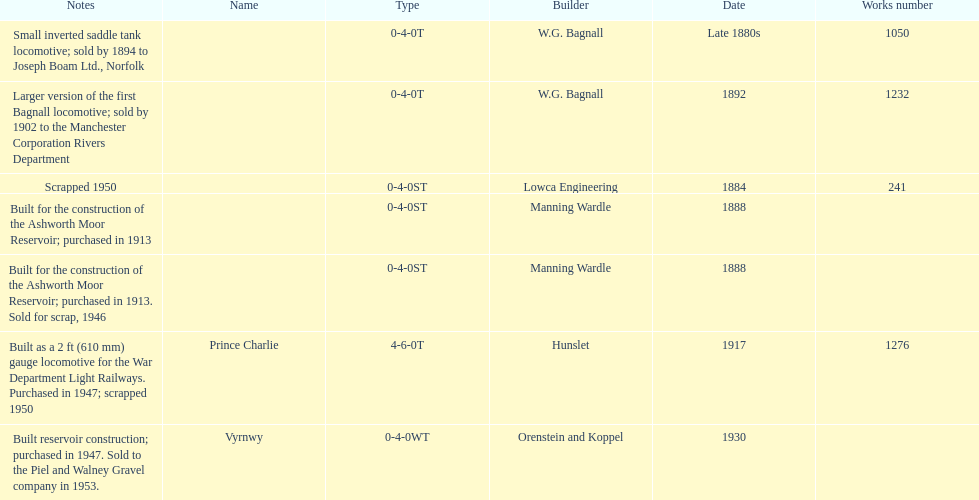How many locomotives were built for the construction of the ashworth moor reservoir? 2. 